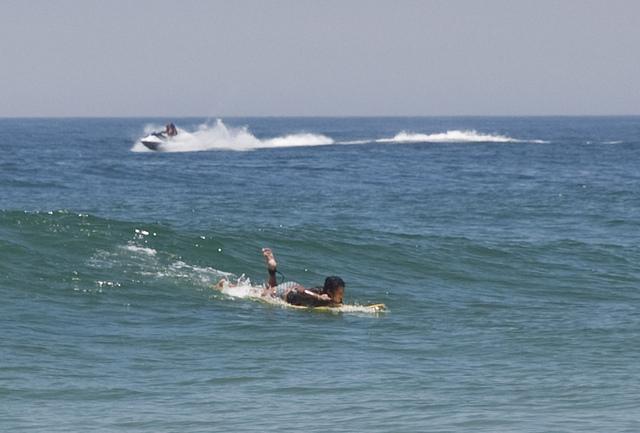What vehicle is in the picture?
Answer briefly. Jet ski. Have you ever been surfing?
Be succinct. No. Where is the jet ski?
Be succinct. Ocean. 